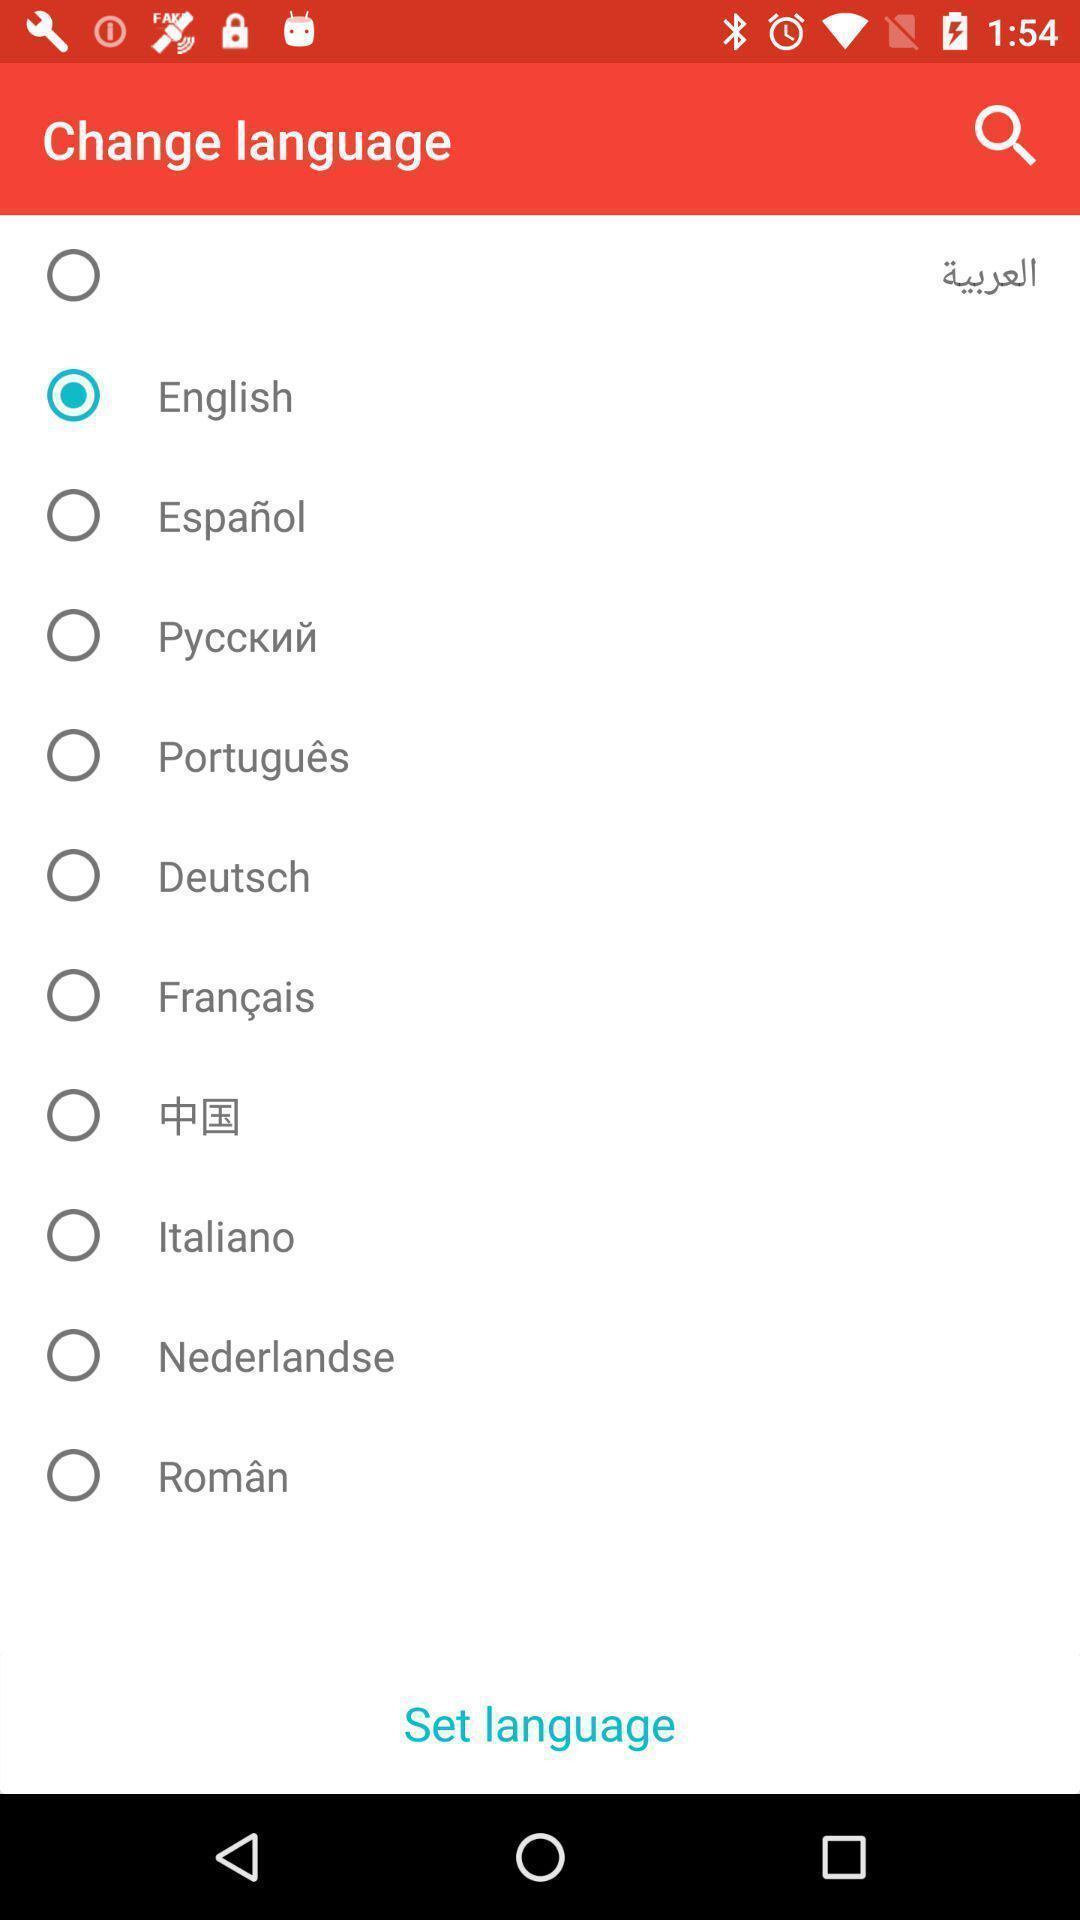Give me a summary of this screen capture. Screen displaying to set language. 